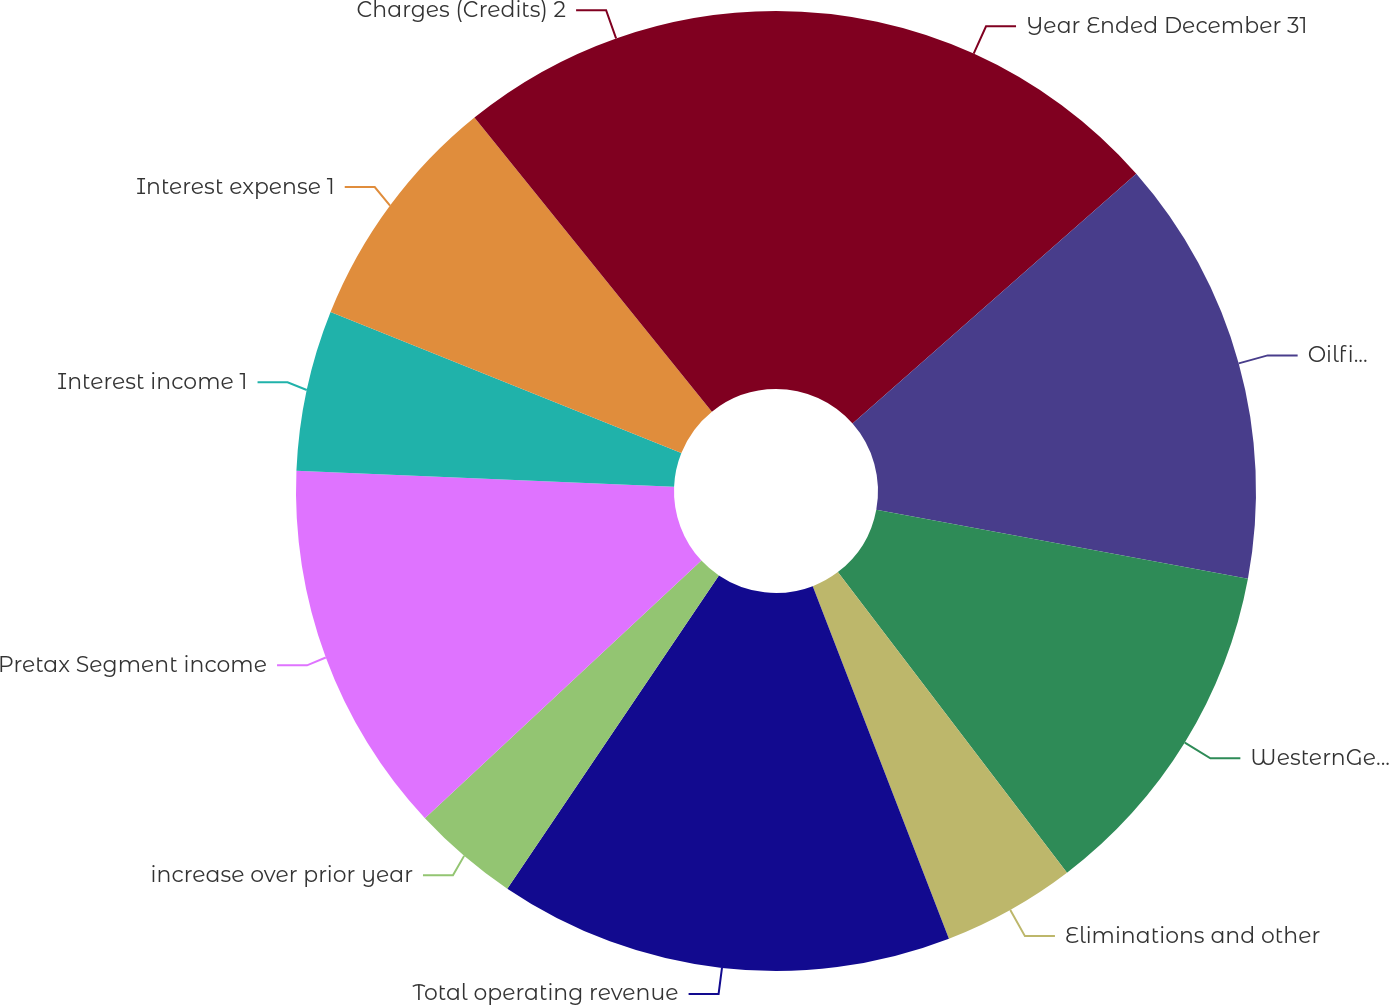Convert chart to OTSL. <chart><loc_0><loc_0><loc_500><loc_500><pie_chart><fcel>Year Ended December 31<fcel>Oilfield Services<fcel>WesternGeco<fcel>Eliminations and other<fcel>Total operating revenue<fcel>increase over prior year<fcel>Pretax Segment income<fcel>Interest income 1<fcel>Interest expense 1<fcel>Charges (Credits) 2<nl><fcel>13.51%<fcel>14.41%<fcel>11.71%<fcel>4.5%<fcel>15.32%<fcel>3.6%<fcel>12.61%<fcel>5.41%<fcel>8.11%<fcel>10.81%<nl></chart> 